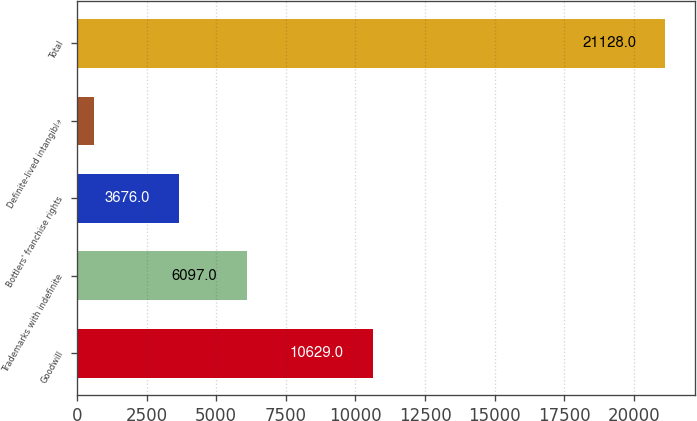<chart> <loc_0><loc_0><loc_500><loc_500><bar_chart><fcel>Goodwill<fcel>Trademarks with indefinite<fcel>Bottlers' franchise rights<fcel>Definite-lived intangible<fcel>Total<nl><fcel>10629<fcel>6097<fcel>3676<fcel>598<fcel>21128<nl></chart> 